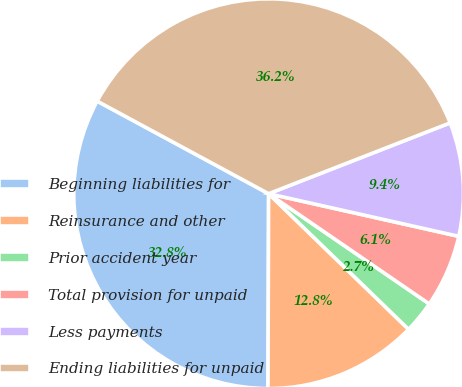Convert chart. <chart><loc_0><loc_0><loc_500><loc_500><pie_chart><fcel>Beginning liabilities for<fcel>Reinsurance and other<fcel>Prior accident year<fcel>Total provision for unpaid<fcel>Less payments<fcel>Ending liabilities for unpaid<nl><fcel>32.83%<fcel>12.8%<fcel>2.68%<fcel>6.06%<fcel>9.43%<fcel>36.2%<nl></chart> 